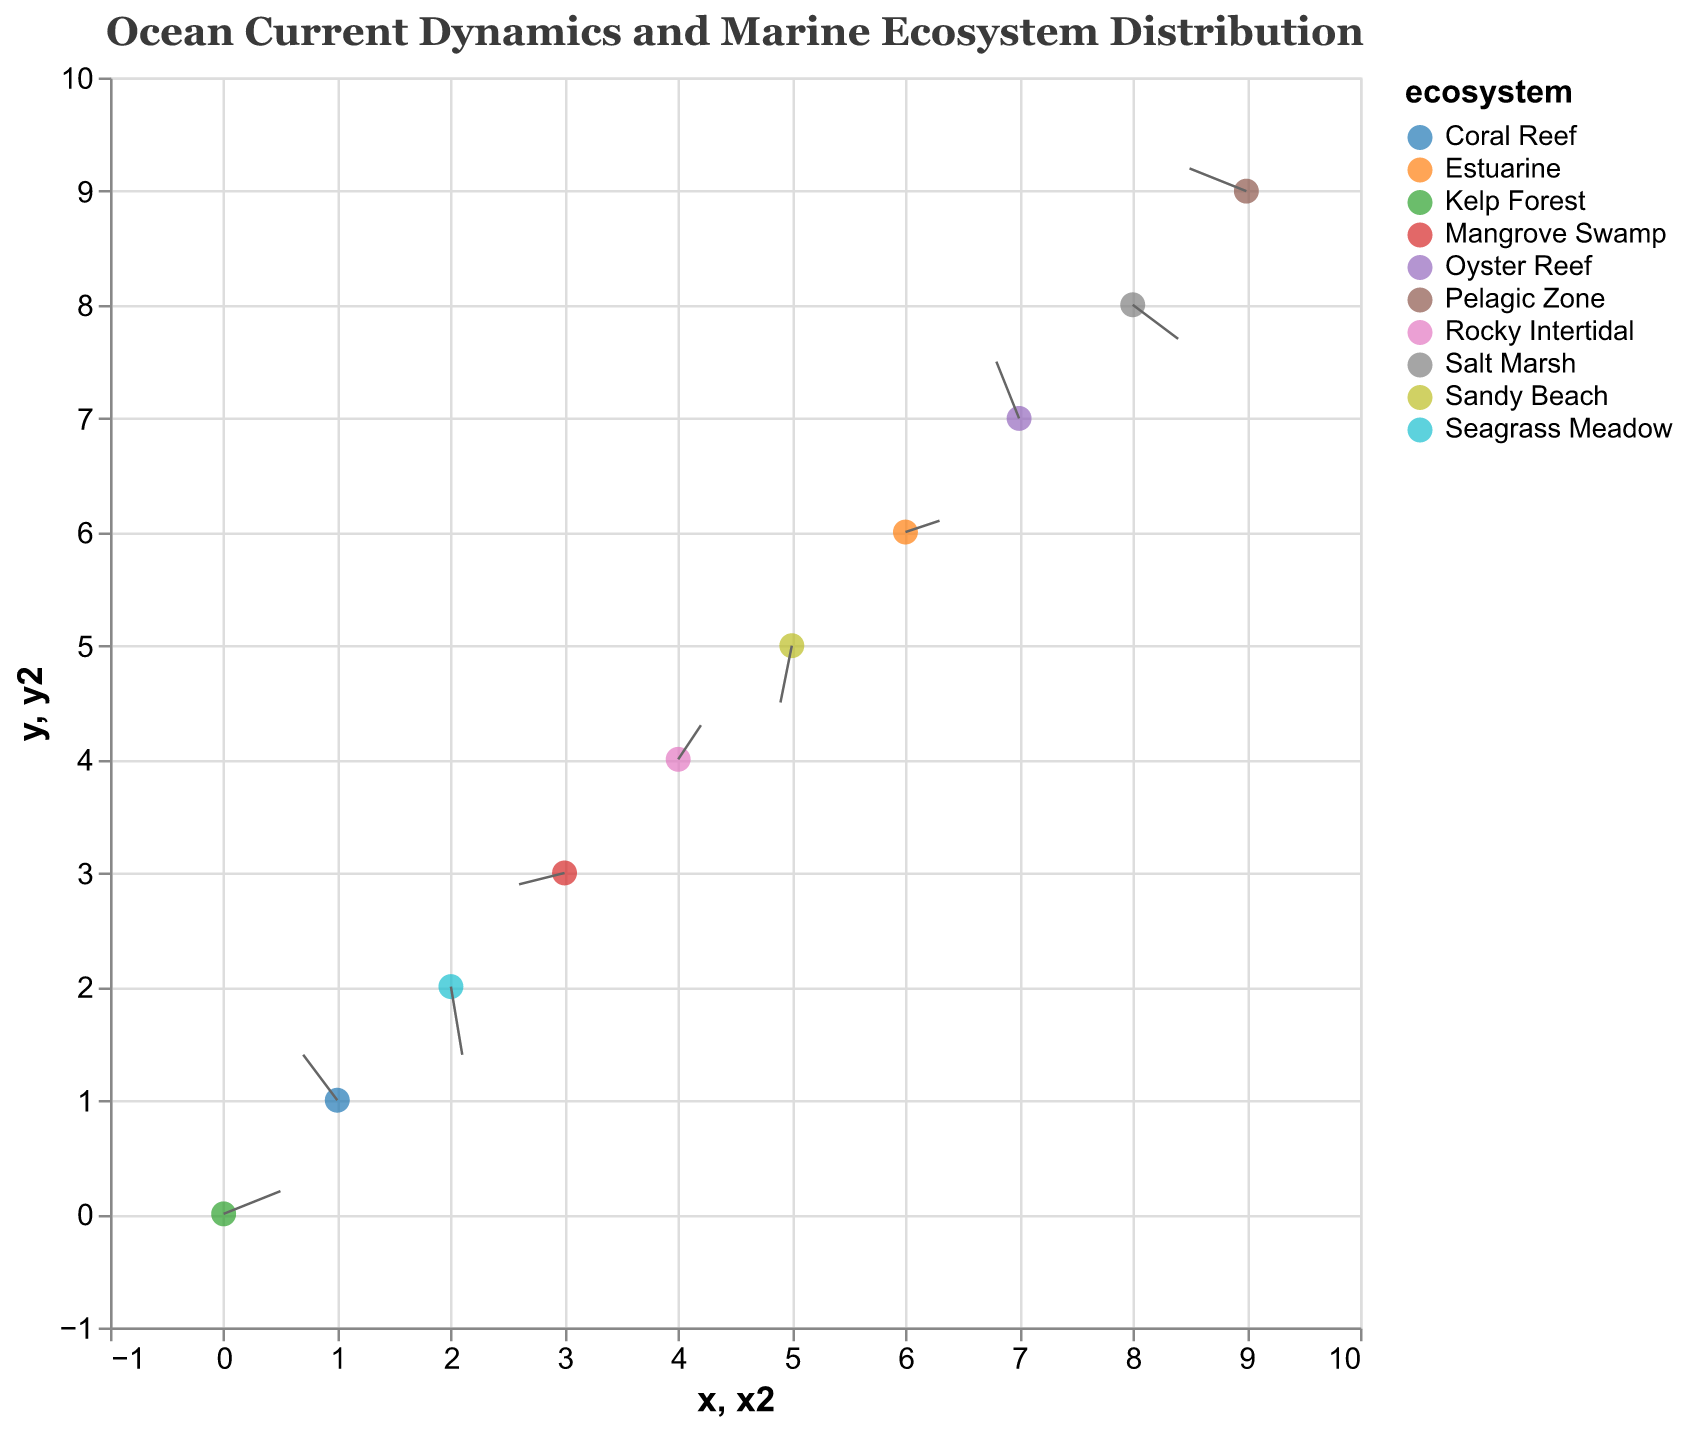What's the title of the figure? The title is usually found at the top of the figure and is intended to provide a summary of what the figure represents.
Answer: Ocean Current Dynamics and Marine Ecosystem Distribution How many ecosystems are represented in the figure? Each unique ecosystem is represented by a different color and is labeled in the legend. Count the number of unique ecosystems in the legend.
Answer: 10 Which ecosystem is located at coordinates (3,3)? Locate the point specifically at coordinates (3,3) and refer to the tooltip or the legend to identify the ecosystem associated with that point.
Answer: Mangrove Swamp What is the magnitude of the current at the Seagrass Meadow? Find the point that corresponds to the Seagrass Meadow from the figure and check the tooltip for the magnitude indicated.
Answer: 0.61 Which ecosystem has the highest current magnitude? Compare the magnitude values of each ecosystem given in the tooltip to find the highest one. Seagrass Meadow has the highest value of 0.61.
Answer: Seagrass Meadow Are there more currents flowing eastward (positive u) or westward (negative u)? Count the number of points where the u component is positive (eastward) versus the number of points where u is negative (westward).
Answer: Eastward: 5, Westward: 5 Which direction is the current flowing at the coordinate (4,4)? Look at the direction of the vector that originates from the point (4,4). The components u and v will tell the direction. For example, if u is positive and v is positive, the current flows northeast.
Answer: Northeast (0.2, 0.3) Do Oyster Reef's currents lead to an increase or decrease in its y-position? Look at the y-component (v) of the current at the Oyster Reef point. If v is positive, it increases the y-position; if negative, it decreases the y-position.
Answer: Increase (v = 0.5) Which two ecosystems have identical current magnitudes? Compare the magnitude values in the tooltip for each ecosystem and identify the ecosystems with the same magnitude value.
Answer: Kelp Forest and Pelagic Zone (both have 0.54) 